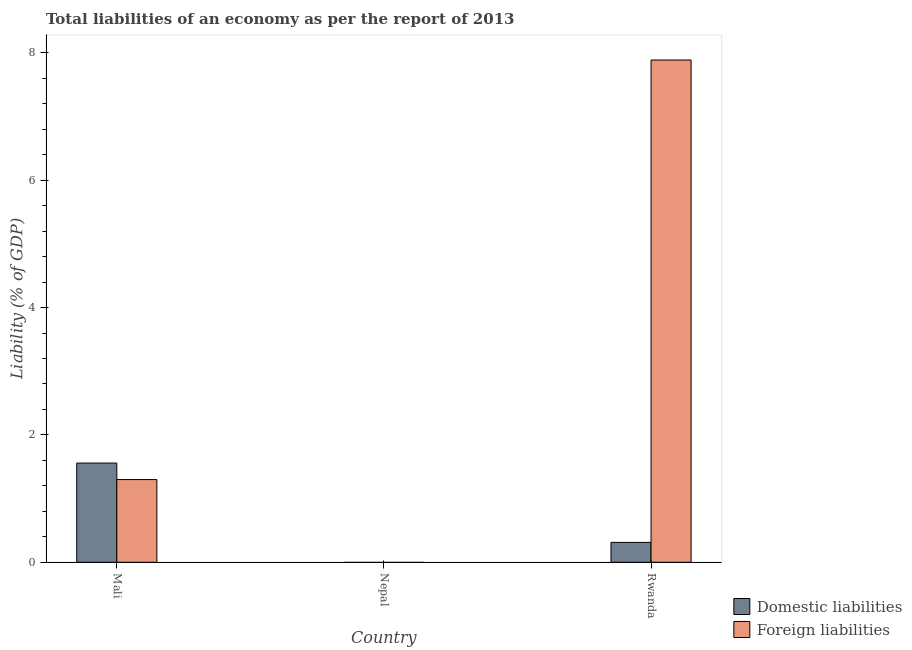How many different coloured bars are there?
Give a very brief answer. 2. Are the number of bars per tick equal to the number of legend labels?
Give a very brief answer. No. How many bars are there on the 3rd tick from the right?
Make the answer very short. 2. What is the label of the 3rd group of bars from the left?
Offer a terse response. Rwanda. In how many cases, is the number of bars for a given country not equal to the number of legend labels?
Provide a short and direct response. 1. Across all countries, what is the maximum incurrence of domestic liabilities?
Ensure brevity in your answer.  1.56. Across all countries, what is the minimum incurrence of domestic liabilities?
Ensure brevity in your answer.  0. In which country was the incurrence of foreign liabilities maximum?
Your answer should be very brief. Rwanda. What is the total incurrence of domestic liabilities in the graph?
Offer a very short reply. 1.87. What is the difference between the incurrence of domestic liabilities in Mali and that in Rwanda?
Your response must be concise. 1.25. What is the difference between the incurrence of foreign liabilities in Mali and the incurrence of domestic liabilities in Nepal?
Ensure brevity in your answer.  1.3. What is the average incurrence of domestic liabilities per country?
Keep it short and to the point. 0.62. What is the difference between the incurrence of domestic liabilities and incurrence of foreign liabilities in Mali?
Make the answer very short. 0.26. What is the ratio of the incurrence of domestic liabilities in Mali to that in Rwanda?
Keep it short and to the point. 4.99. Is the incurrence of foreign liabilities in Mali less than that in Rwanda?
Keep it short and to the point. Yes. Is the difference between the incurrence of domestic liabilities in Mali and Rwanda greater than the difference between the incurrence of foreign liabilities in Mali and Rwanda?
Offer a terse response. Yes. What is the difference between the highest and the lowest incurrence of foreign liabilities?
Offer a terse response. 7.89. Is the sum of the incurrence of domestic liabilities in Mali and Rwanda greater than the maximum incurrence of foreign liabilities across all countries?
Make the answer very short. No. How many bars are there?
Make the answer very short. 4. Are all the bars in the graph horizontal?
Keep it short and to the point. No. What is the difference between two consecutive major ticks on the Y-axis?
Give a very brief answer. 2. Does the graph contain grids?
Your answer should be very brief. No. How many legend labels are there?
Offer a terse response. 2. How are the legend labels stacked?
Make the answer very short. Vertical. What is the title of the graph?
Keep it short and to the point. Total liabilities of an economy as per the report of 2013. Does "Crop" appear as one of the legend labels in the graph?
Offer a terse response. No. What is the label or title of the X-axis?
Make the answer very short. Country. What is the label or title of the Y-axis?
Make the answer very short. Liability (% of GDP). What is the Liability (% of GDP) of Domestic liabilities in Mali?
Provide a succinct answer. 1.56. What is the Liability (% of GDP) of Foreign liabilities in Mali?
Your answer should be very brief. 1.3. What is the Liability (% of GDP) in Domestic liabilities in Nepal?
Offer a terse response. 0. What is the Liability (% of GDP) in Domestic liabilities in Rwanda?
Offer a terse response. 0.31. What is the Liability (% of GDP) in Foreign liabilities in Rwanda?
Provide a short and direct response. 7.89. Across all countries, what is the maximum Liability (% of GDP) in Domestic liabilities?
Offer a very short reply. 1.56. Across all countries, what is the maximum Liability (% of GDP) of Foreign liabilities?
Ensure brevity in your answer.  7.89. Across all countries, what is the minimum Liability (% of GDP) in Domestic liabilities?
Your response must be concise. 0. Across all countries, what is the minimum Liability (% of GDP) in Foreign liabilities?
Your response must be concise. 0. What is the total Liability (% of GDP) in Domestic liabilities in the graph?
Offer a very short reply. 1.87. What is the total Liability (% of GDP) of Foreign liabilities in the graph?
Your response must be concise. 9.19. What is the difference between the Liability (% of GDP) of Domestic liabilities in Mali and that in Rwanda?
Your response must be concise. 1.25. What is the difference between the Liability (% of GDP) of Foreign liabilities in Mali and that in Rwanda?
Offer a terse response. -6.59. What is the difference between the Liability (% of GDP) of Domestic liabilities in Mali and the Liability (% of GDP) of Foreign liabilities in Rwanda?
Your answer should be very brief. -6.33. What is the average Liability (% of GDP) in Domestic liabilities per country?
Your answer should be compact. 0.62. What is the average Liability (% of GDP) of Foreign liabilities per country?
Your response must be concise. 3.06. What is the difference between the Liability (% of GDP) in Domestic liabilities and Liability (% of GDP) in Foreign liabilities in Mali?
Your answer should be compact. 0.26. What is the difference between the Liability (% of GDP) in Domestic liabilities and Liability (% of GDP) in Foreign liabilities in Rwanda?
Keep it short and to the point. -7.58. What is the ratio of the Liability (% of GDP) of Domestic liabilities in Mali to that in Rwanda?
Ensure brevity in your answer.  4.99. What is the ratio of the Liability (% of GDP) in Foreign liabilities in Mali to that in Rwanda?
Your answer should be very brief. 0.16. What is the difference between the highest and the lowest Liability (% of GDP) of Domestic liabilities?
Offer a very short reply. 1.56. What is the difference between the highest and the lowest Liability (% of GDP) in Foreign liabilities?
Offer a very short reply. 7.89. 